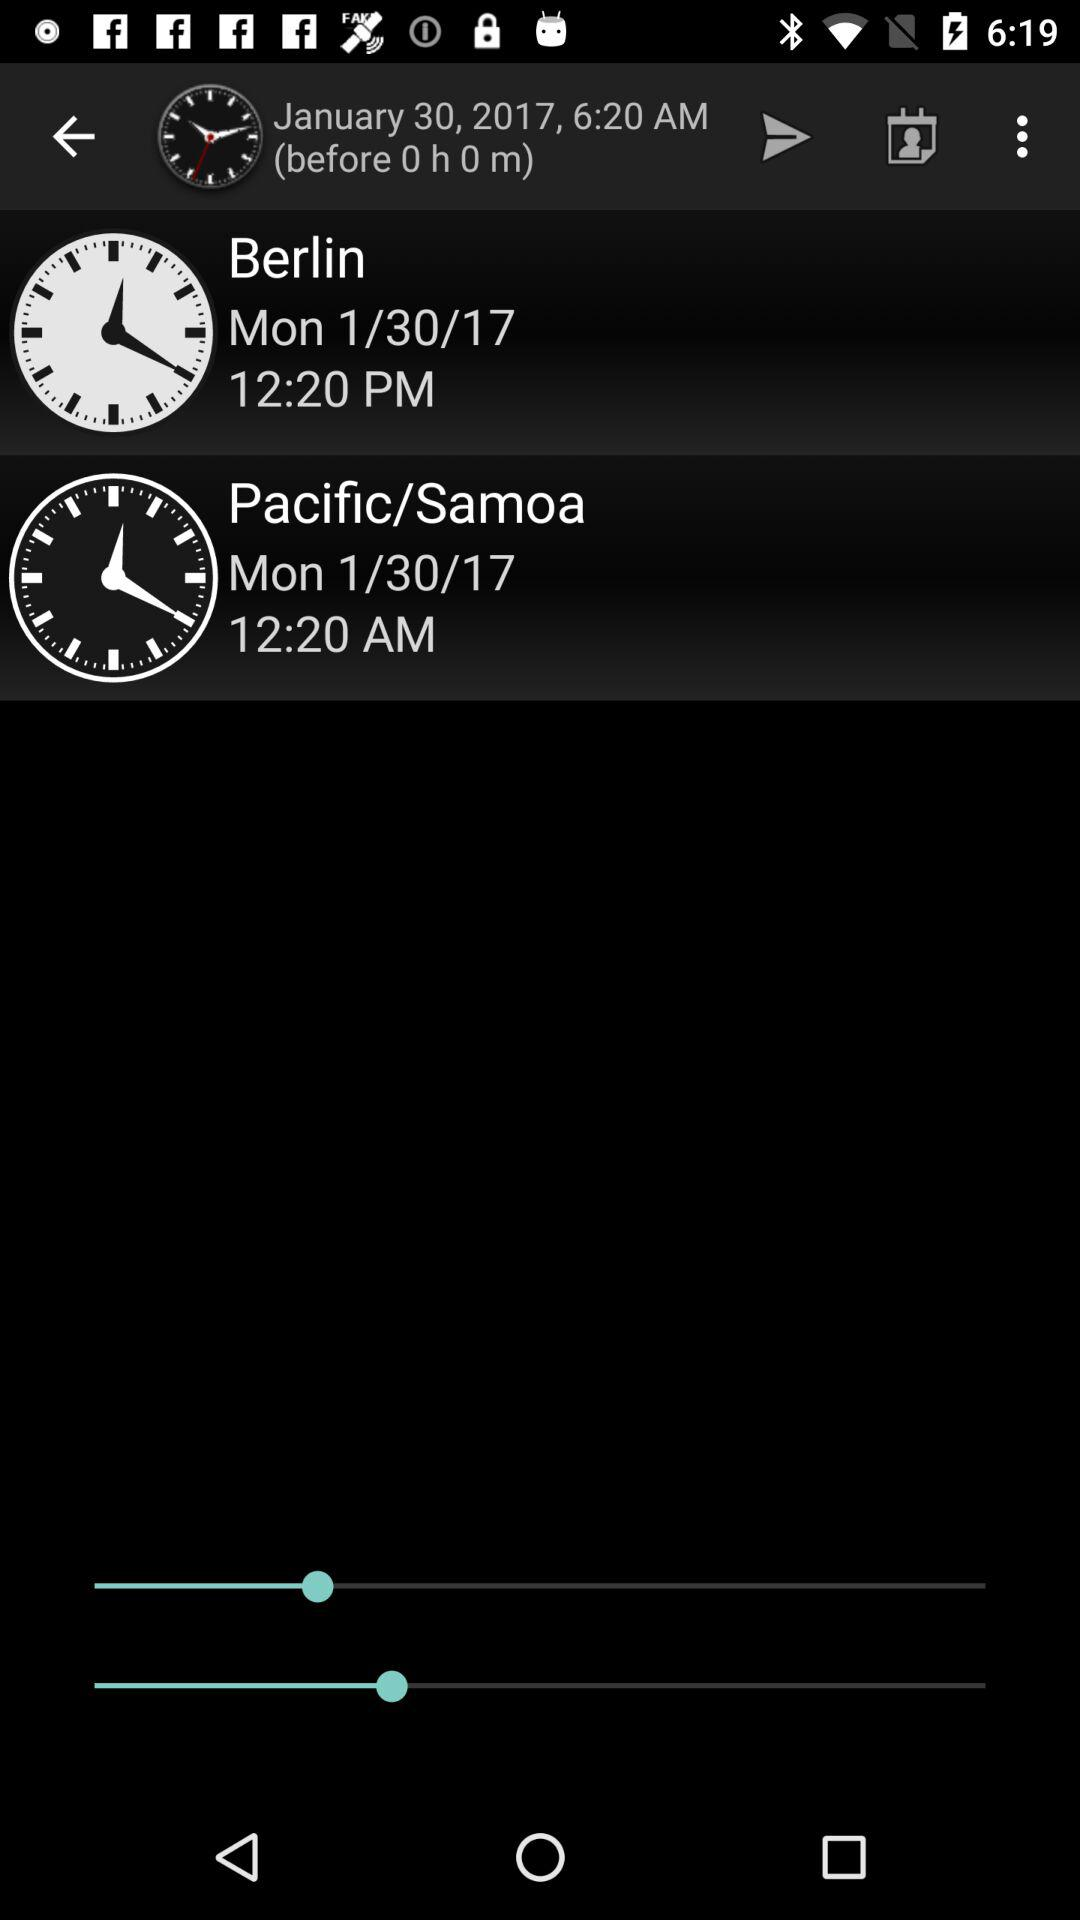What is the difference in time between Berlin and Pacific/Samoa?
Answer the question using a single word or phrase. 12 hours 